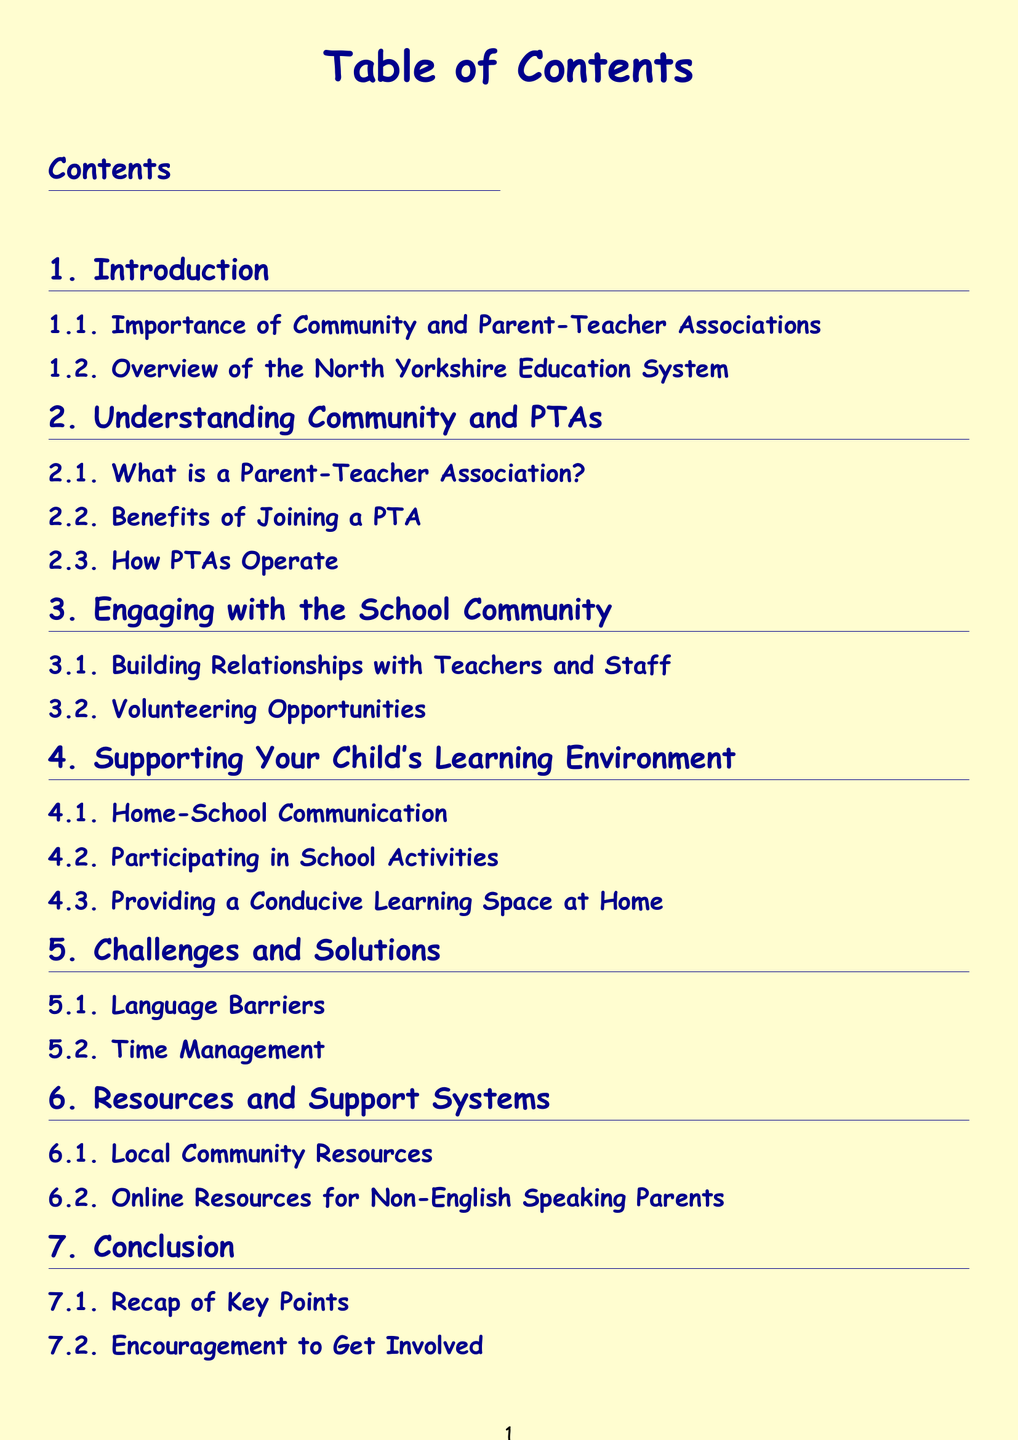What is the first section in the document? The first section is "Introduction".
Answer: Introduction What is the title of the second subsection in the "Engaging with the School Community" section? The second subsection is "Volunteering Opportunities".
Answer: Volunteering Opportunities What type of barriers are discussed in the "Challenges and Solutions" section? The section discusses "Language Barriers".
Answer: Language Barriers How many subsections does the "Supporting Your Child's Learning Environment" section have? The section has three subsections.
Answer: Three What is one of the resources mentioned for non-English speaking parents? The section lists "Online Resources for Non-English Speaking Parents".
Answer: Online Resources for Non-English Speaking Parents What is the last subsection of the document? The last subsection is "Encouragement to Get Involved".
Answer: Encouragement to Get Involved What section discusses the benefits of joining a PTA? The section is "Understanding Community and PTAs".
Answer: Understanding Community and PTAs What color is used for the document's background? The document's background is "lightyellow".
Answer: lightyellow What is emphasized in the "Home-School Communication" subsection? The subsection emphasizes communication between home and school.
Answer: communication between home and school 